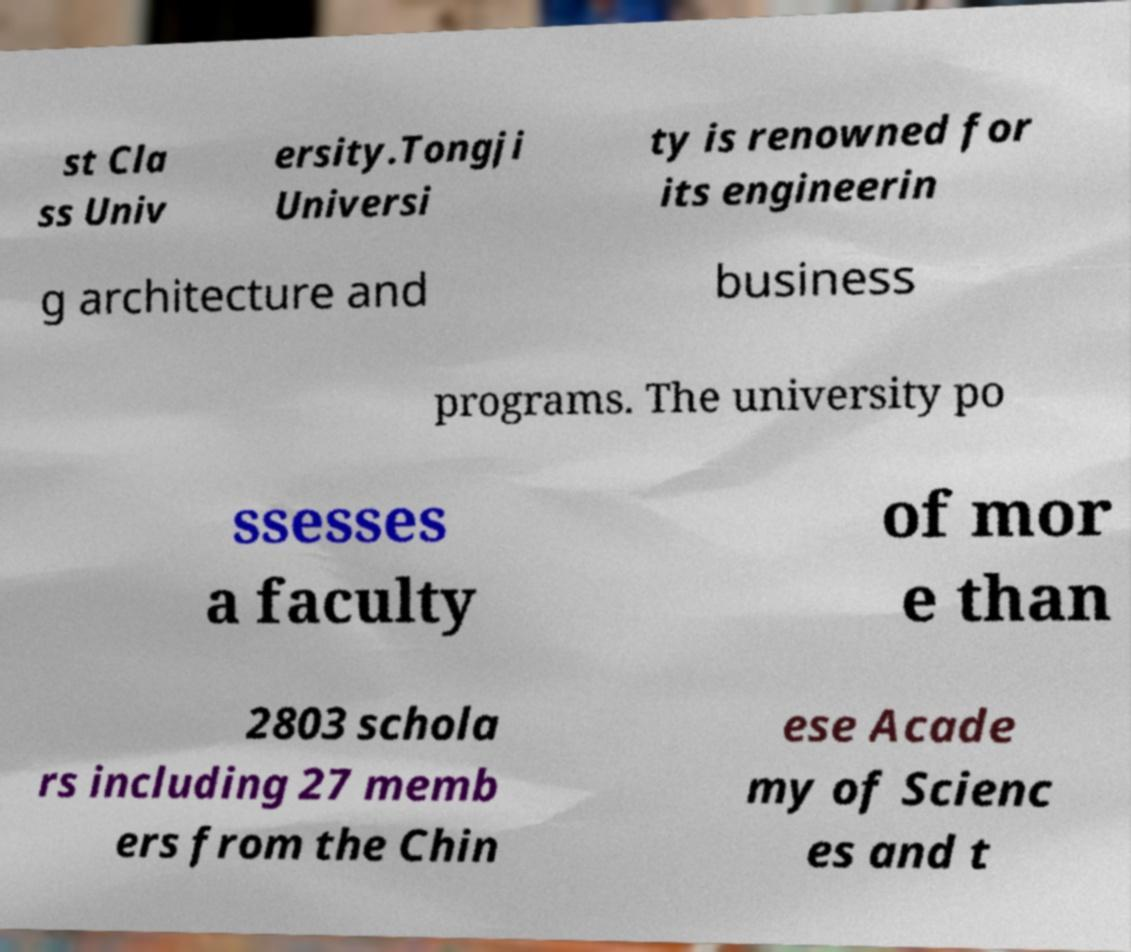Could you assist in decoding the text presented in this image and type it out clearly? st Cla ss Univ ersity.Tongji Universi ty is renowned for its engineerin g architecture and business programs. The university po ssesses a faculty of mor e than 2803 schola rs including 27 memb ers from the Chin ese Acade my of Scienc es and t 